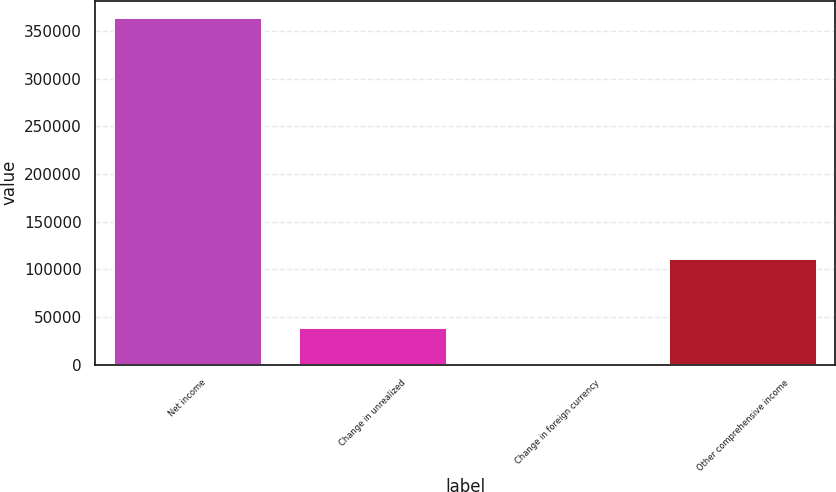<chart> <loc_0><loc_0><loc_500><loc_500><bar_chart><fcel>Net income<fcel>Change in unrealized<fcel>Change in foreign currency<fcel>Other comprehensive income<nl><fcel>363628<fcel>38198.8<fcel>2040<fcel>110516<nl></chart> 